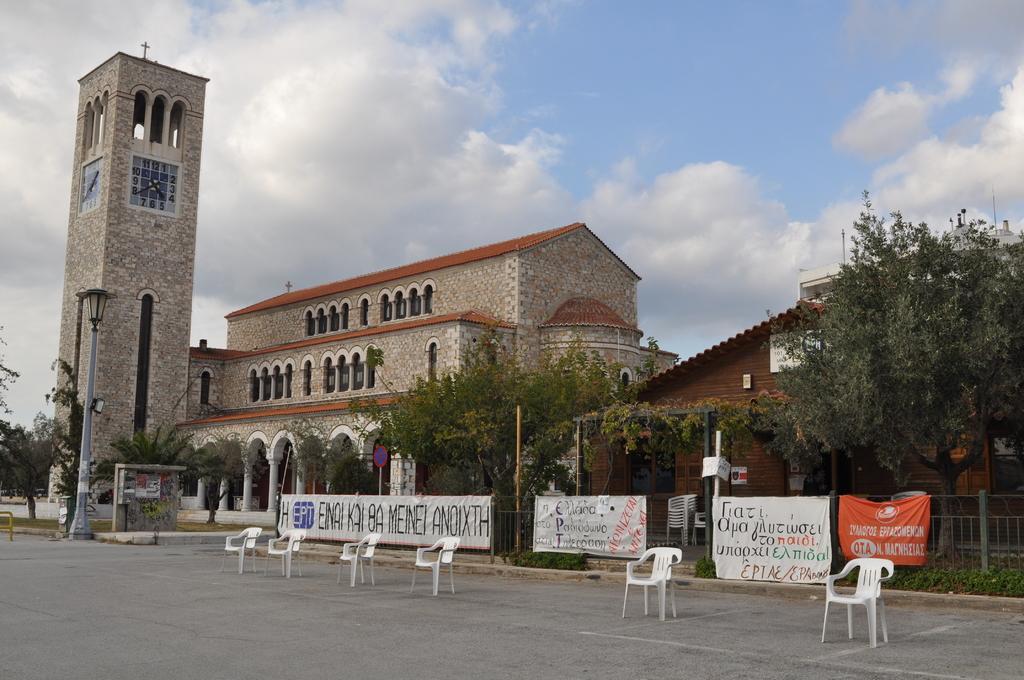In one or two sentences, can you explain what this image depicts? This image is taken outdoors. At the bottom of the image there is a road. At the top of the image there is a sky with clouds. In the middle of the image there are a few houses and a church with walls, windows, pillars, doors and roofs and there are a few trees, plants and there is a street light, a railing and a few banners with text on them. There are a few empty chairs on the road. 